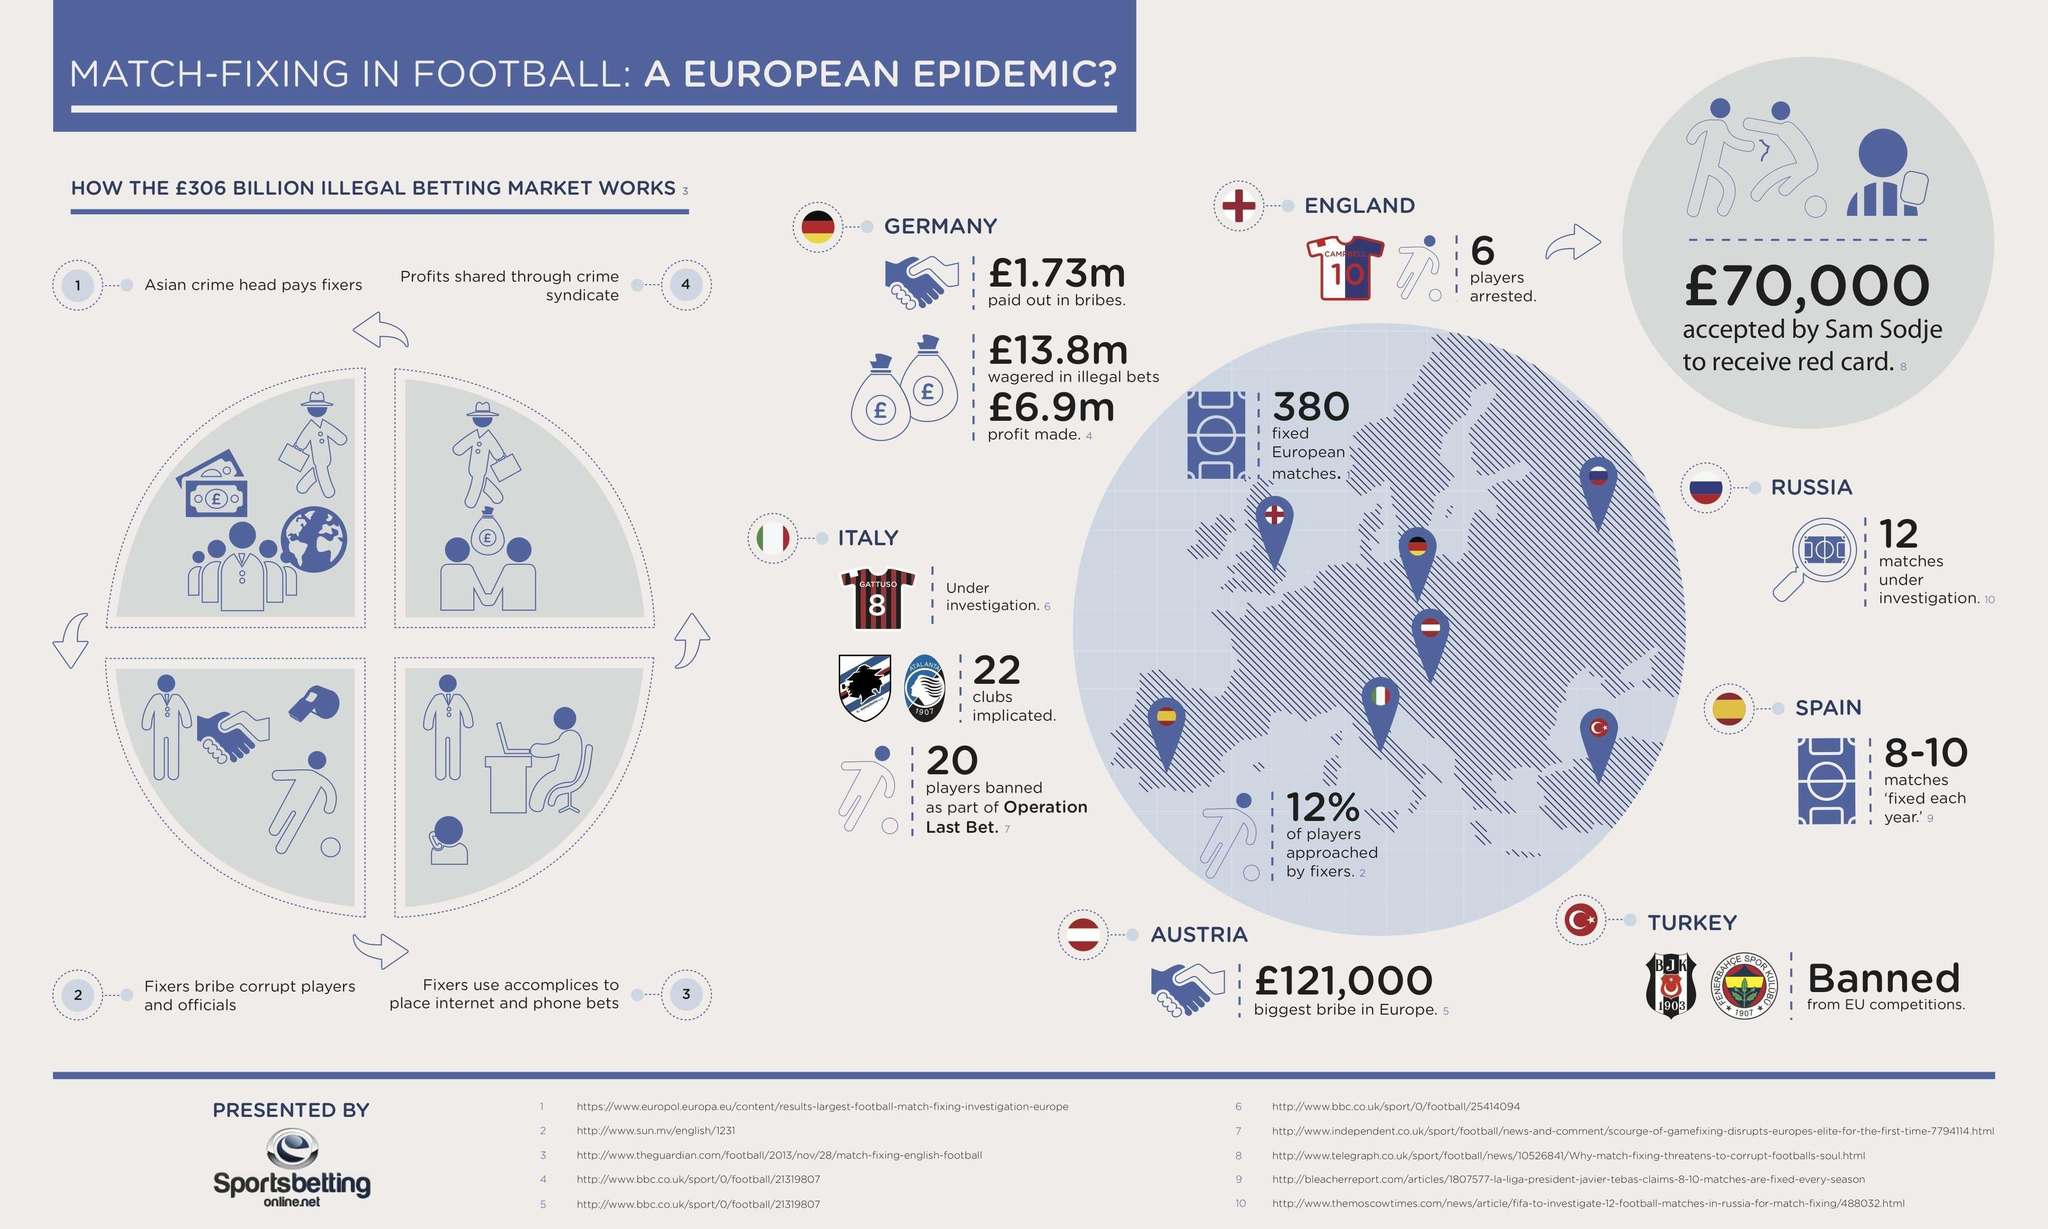Which channel is used to share the profit from betting?
Answer the question with a short phrase. Crime Syndicate What is the number on England's Jersey? 10 How many Italian clubs were implicated? 22 How many Italian players were banned as part of Operation Last Bet? 20 What is the number on the Italian football jersey? 8 How many English football players were arrested? 6 How many location pins are shown on the map of Europe? 7 Which European country has paid the biggest bribe? Austria Who places the bet on internet  for the fixers? Accomplices Which country is banned from EU competitions? Turkey Who willingly took a red card for a huge bribe? Sam Sodje Which country does Sam Sodje play for? England What do fixers do, after they receive payment from Asian crime head? Fixers bribe or corrupt players and officials The flag of which country has a moon and a star on it? Turkey 